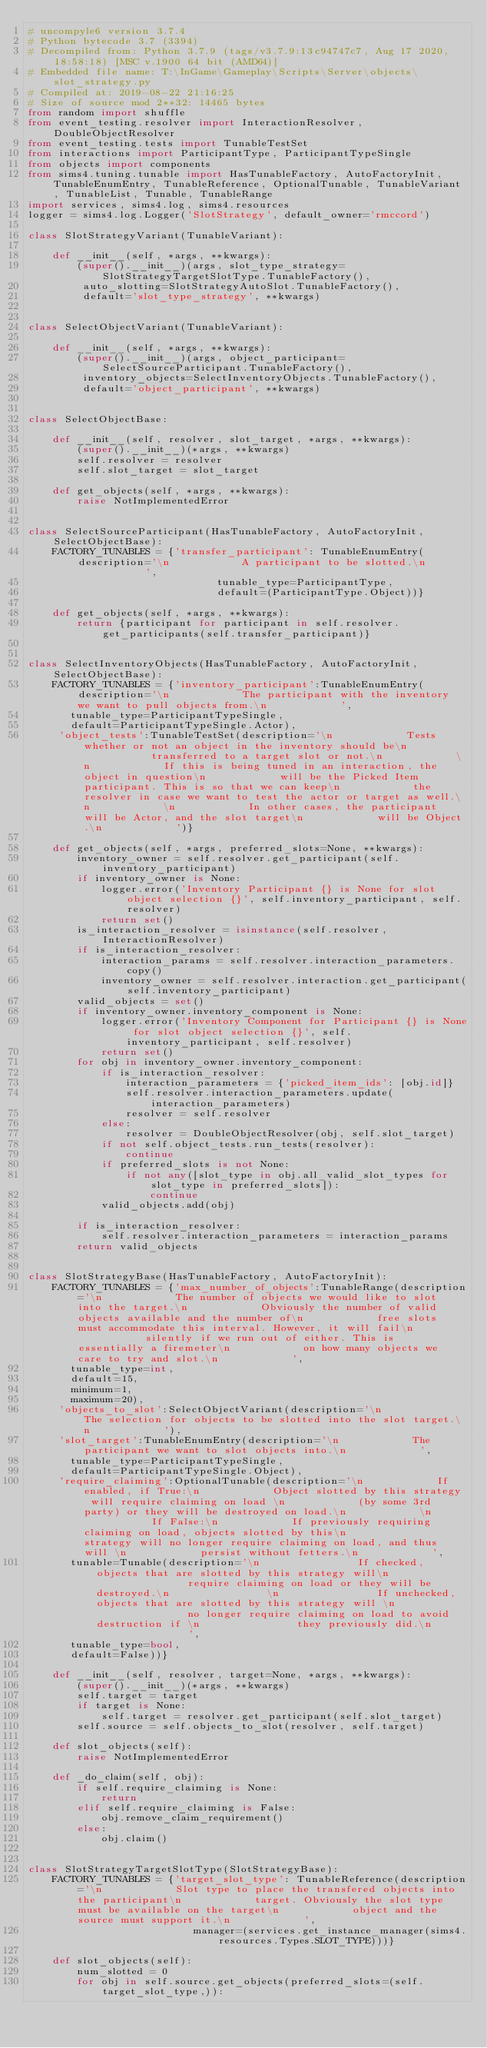<code> <loc_0><loc_0><loc_500><loc_500><_Python_># uncompyle6 version 3.7.4
# Python bytecode 3.7 (3394)
# Decompiled from: Python 3.7.9 (tags/v3.7.9:13c94747c7, Aug 17 2020, 18:58:18) [MSC v.1900 64 bit (AMD64)]
# Embedded file name: T:\InGame\Gameplay\Scripts\Server\objects\slot_strategy.py
# Compiled at: 2019-08-22 21:16:25
# Size of source mod 2**32: 14465 bytes
from random import shuffle
from event_testing.resolver import InteractionResolver, DoubleObjectResolver
from event_testing.tests import TunableTestSet
from interactions import ParticipantType, ParticipantTypeSingle
from objects import components
from sims4.tuning.tunable import HasTunableFactory, AutoFactoryInit, TunableEnumEntry, TunableReference, OptionalTunable, TunableVariant, TunableList, Tunable, TunableRange
import services, sims4.log, sims4.resources
logger = sims4.log.Logger('SlotStrategy', default_owner='rmccord')

class SlotStrategyVariant(TunableVariant):

    def __init__(self, *args, **kwargs):
        (super().__init__)(args, slot_type_strategy=SlotStrategyTargetSlotType.TunableFactory(), 
         auto_slotting=SlotStrategyAutoSlot.TunableFactory(), 
         default='slot_type_strategy', **kwargs)


class SelectObjectVariant(TunableVariant):

    def __init__(self, *args, **kwargs):
        (super().__init__)(args, object_participant=SelectSourceParticipant.TunableFactory(), 
         inventory_objects=SelectInventoryObjects.TunableFactory(), 
         default='object_participant', **kwargs)


class SelectObjectBase:

    def __init__(self, resolver, slot_target, *args, **kwargs):
        (super().__init__)(*args, **kwargs)
        self.resolver = resolver
        self.slot_target = slot_target

    def get_objects(self, *args, **kwargs):
        raise NotImplementedError


class SelectSourceParticipant(HasTunableFactory, AutoFactoryInit, SelectObjectBase):
    FACTORY_TUNABLES = {'transfer_participant': TunableEnumEntry(description='\n            A participant to be slotted.\n            ',
                               tunable_type=ParticipantType,
                               default=(ParticipantType.Object))}

    def get_objects(self, *args, **kwargs):
        return {participant for participant in self.resolver.get_participants(self.transfer_participant)}


class SelectInventoryObjects(HasTunableFactory, AutoFactoryInit, SelectObjectBase):
    FACTORY_TUNABLES = {'inventory_participant':TunableEnumEntry(description='\n            The participant with the inventory we want to pull objects from.\n            ',
       tunable_type=ParticipantTypeSingle,
       default=ParticipantTypeSingle.Actor), 
     'object_tests':TunableTestSet(description='\n            Tests whether or not an object in the inventory should be\n            transferred to a target slot or not.\n            \n            If this is being tuned in an interaction, the object in question\n            will be the Picked Item participant. This is so that we can keep\n            the resolver in case we want to test the actor or target as well.\n            \n            In other cases, the participant will be Actor, and the slot target\n            will be Object.\n            ')}

    def get_objects(self, *args, preferred_slots=None, **kwargs):
        inventory_owner = self.resolver.get_participant(self.inventory_participant)
        if inventory_owner is None:
            logger.error('Inventory Participant {} is None for slot object selection {}', self.inventory_participant, self.resolver)
            return set()
        is_interaction_resolver = isinstance(self.resolver, InteractionResolver)
        if is_interaction_resolver:
            interaction_params = self.resolver.interaction_parameters.copy()
            inventory_owner = self.resolver.interaction.get_participant(self.inventory_participant)
        valid_objects = set()
        if inventory_owner.inventory_component is None:
            logger.error('Inventory Component for Participant {} is None for slot object selection {}', self.inventory_participant, self.resolver)
            return set()
        for obj in inventory_owner.inventory_component:
            if is_interaction_resolver:
                interaction_parameters = {'picked_item_ids': [obj.id]}
                self.resolver.interaction_parameters.update(interaction_parameters)
                resolver = self.resolver
            else:
                resolver = DoubleObjectResolver(obj, self.slot_target)
            if not self.object_tests.run_tests(resolver):
                continue
            if preferred_slots is not None:
                if not any([slot_type in obj.all_valid_slot_types for slot_type in preferred_slots]):
                    continue
            valid_objects.add(obj)

        if is_interaction_resolver:
            self.resolver.interaction_parameters = interaction_params
        return valid_objects


class SlotStrategyBase(HasTunableFactory, AutoFactoryInit):
    FACTORY_TUNABLES = {'max_number_of_objects':TunableRange(description='\n            The number of objects we would like to slot into the target.\n            Obviously the number of valid objects available and the number of\n            free slots must accommodate this interval. However, it will fail\n            silently if we run out of either. This is essentially a firemeter\n            on how many objects we care to try and slot.\n            ',
       tunable_type=int,
       default=15,
       minimum=1,
       maximum=20), 
     'objects_to_slot':SelectObjectVariant(description='\n            The selection for objects to be slotted into the slot target.\n            '), 
     'slot_target':TunableEnumEntry(description='\n            The participant we want to slot objects into.\n            ',
       tunable_type=ParticipantTypeSingle,
       default=ParticipantTypeSingle.Object), 
     'require_claiming':OptionalTunable(description='\n            If enabled, if True:\n            Object slotted by this strategy will require claiming on load \n            (by some 3rd party) or they will be destroyed on load.\n            \n            If False:\n            If previously requiring claiming on load, objects slotted by this\n            strategy will no longer require claiming on load, and thus will \n            persist without fetters.\n            ',
       tunable=Tunable(description='\n                If checked, objects that are slotted by this strategy will\n                require claiming on load or they will be destroyed.\n                \n                If unchecked, objects that are slotted by this strategy will \n                no longer require claiming on load to avoid destruction if \n                they previously did.\n                ',
       tunable_type=bool,
       default=False))}

    def __init__(self, resolver, target=None, *args, **kwargs):
        (super().__init__)(*args, **kwargs)
        self.target = target
        if target is None:
            self.target = resolver.get_participant(self.slot_target)
        self.source = self.objects_to_slot(resolver, self.target)

    def slot_objects(self):
        raise NotImplementedError

    def _do_claim(self, obj):
        if self.require_claiming is None:
            return
        elif self.require_claiming is False:
            obj.remove_claim_requirement()
        else:
            obj.claim()


class SlotStrategyTargetSlotType(SlotStrategyBase):
    FACTORY_TUNABLES = {'target_slot_type': TunableReference(description='\n            Slot type to place the transfered objects into the participant\n            target. Obviously the slot type must be available on the target\n            object and the source must support it.\n            ',
                           manager=(services.get_instance_manager(sims4.resources.Types.SLOT_TYPE)))}

    def slot_objects(self):
        num_slotted = 0
        for obj in self.source.get_objects(preferred_slots=(self.target_slot_type,)):</code> 